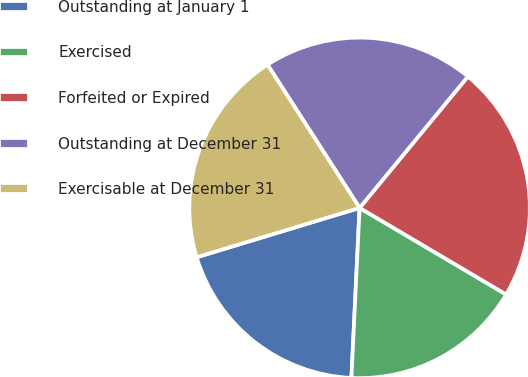<chart> <loc_0><loc_0><loc_500><loc_500><pie_chart><fcel>Outstanding at January 1<fcel>Exercised<fcel>Forfeited or Expired<fcel>Outstanding at December 31<fcel>Exercisable at December 31<nl><fcel>19.55%<fcel>17.27%<fcel>22.52%<fcel>20.07%<fcel>20.59%<nl></chart> 